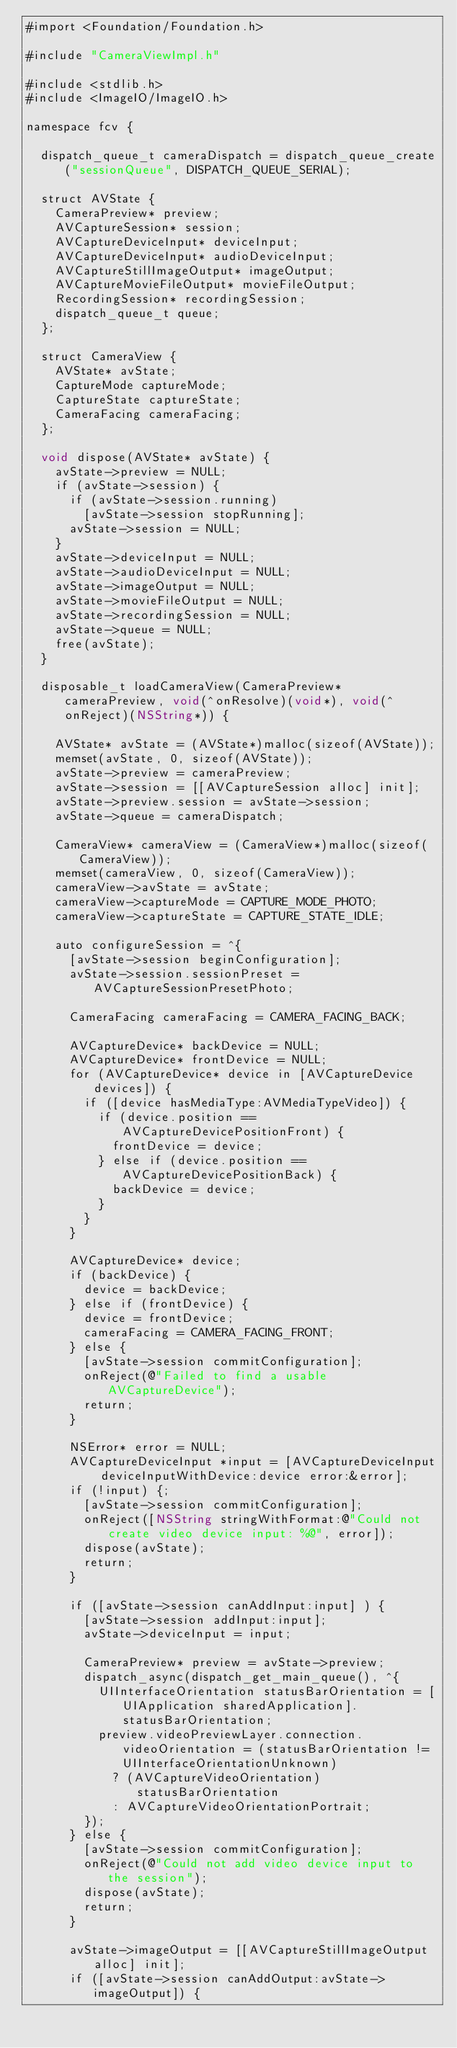Convert code to text. <code><loc_0><loc_0><loc_500><loc_500><_ObjectiveC_>#import <Foundation/Foundation.h>

#include "CameraViewImpl.h"

#include <stdlib.h>
#include <ImageIO/ImageIO.h>

namespace fcv {

	dispatch_queue_t cameraDispatch = dispatch_queue_create("sessionQueue", DISPATCH_QUEUE_SERIAL);

	struct AVState {
		CameraPreview* preview;
		AVCaptureSession* session;
		AVCaptureDeviceInput* deviceInput;
		AVCaptureDeviceInput* audioDeviceInput;
		AVCaptureStillImageOutput* imageOutput;
		AVCaptureMovieFileOutput* movieFileOutput;
		RecordingSession* recordingSession;
		dispatch_queue_t queue;
	};

	struct CameraView {
		AVState* avState;
		CaptureMode captureMode;
		CaptureState captureState;
		CameraFacing cameraFacing;
	};

	void dispose(AVState* avState) {
		avState->preview = NULL;
		if (avState->session) {
			if (avState->session.running)
				[avState->session stopRunning];
			avState->session = NULL;
		}
		avState->deviceInput = NULL;
		avState->audioDeviceInput = NULL;
		avState->imageOutput = NULL;
		avState->movieFileOutput = NULL;
		avState->recordingSession = NULL;
		avState->queue = NULL;
		free(avState);
	}

	disposable_t loadCameraView(CameraPreview* cameraPreview, void(^onResolve)(void*), void(^onReject)(NSString*)) {

		AVState* avState = (AVState*)malloc(sizeof(AVState));
		memset(avState, 0, sizeof(AVState));
		avState->preview = cameraPreview;
		avState->session = [[AVCaptureSession alloc] init];
		avState->preview.session = avState->session;
		avState->queue = cameraDispatch;

		CameraView* cameraView = (CameraView*)malloc(sizeof(CameraView));
		memset(cameraView, 0, sizeof(CameraView));
		cameraView->avState = avState;
		cameraView->captureMode = CAPTURE_MODE_PHOTO;
		cameraView->captureState = CAPTURE_STATE_IDLE;

		auto configureSession = ^{
			[avState->session beginConfiguration];
			avState->session.sessionPreset = AVCaptureSessionPresetPhoto;

			CameraFacing cameraFacing = CAMERA_FACING_BACK;

			AVCaptureDevice* backDevice = NULL;
			AVCaptureDevice* frontDevice = NULL;
			for (AVCaptureDevice* device in [AVCaptureDevice devices]) {
				if ([device hasMediaType:AVMediaTypeVideo]) {
					if (device.position == AVCaptureDevicePositionFront) {
						frontDevice = device;
					} else if (device.position == AVCaptureDevicePositionBack) {
						backDevice = device;
					}
				}
			}

			AVCaptureDevice* device;
			if (backDevice) {
				device = backDevice;
			} else if (frontDevice) {
				device = frontDevice;
				cameraFacing = CAMERA_FACING_FRONT;
			} else {
				[avState->session commitConfiguration];
				onReject(@"Failed to find a usable AVCaptureDevice");
				return;
			}

			NSError* error = NULL;
			AVCaptureDeviceInput *input = [AVCaptureDeviceInput deviceInputWithDevice:device error:&error];
			if (!input) {;
				[avState->session commitConfiguration];
				onReject([NSString stringWithFormat:@"Could not create video device input: %@", error]);
				dispose(avState);
				return;
			}

			if ([avState->session canAddInput:input] ) {
				[avState->session addInput:input];
				avState->deviceInput = input;

				CameraPreview* preview = avState->preview;
				dispatch_async(dispatch_get_main_queue(), ^{
					UIInterfaceOrientation statusBarOrientation = [UIApplication sharedApplication].statusBarOrientation;
					preview.videoPreviewLayer.connection.videoOrientation = (statusBarOrientation != UIInterfaceOrientationUnknown)
						? (AVCaptureVideoOrientation)statusBarOrientation
						: AVCaptureVideoOrientationPortrait;
				});
			} else {
				[avState->session commitConfiguration];
				onReject(@"Could not add video device input to the session");
				dispose(avState);
				return;
			}

			avState->imageOutput = [[AVCaptureStillImageOutput alloc] init];
			if ([avState->session canAddOutput:avState->imageOutput]) {</code> 